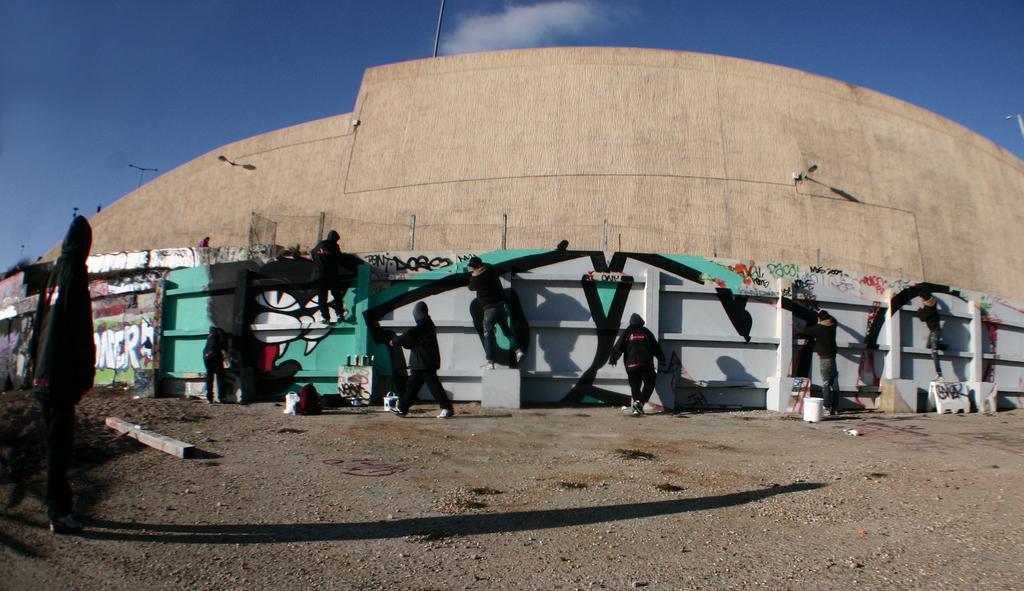Please provide a concise description of this image. Here in this picture we can see a group of people in black colored dress, standing and walking on the ground over there and we can see some are painting the wall with graffiti and above that we can see light posts all over there and we can also see clouds in the sky. 